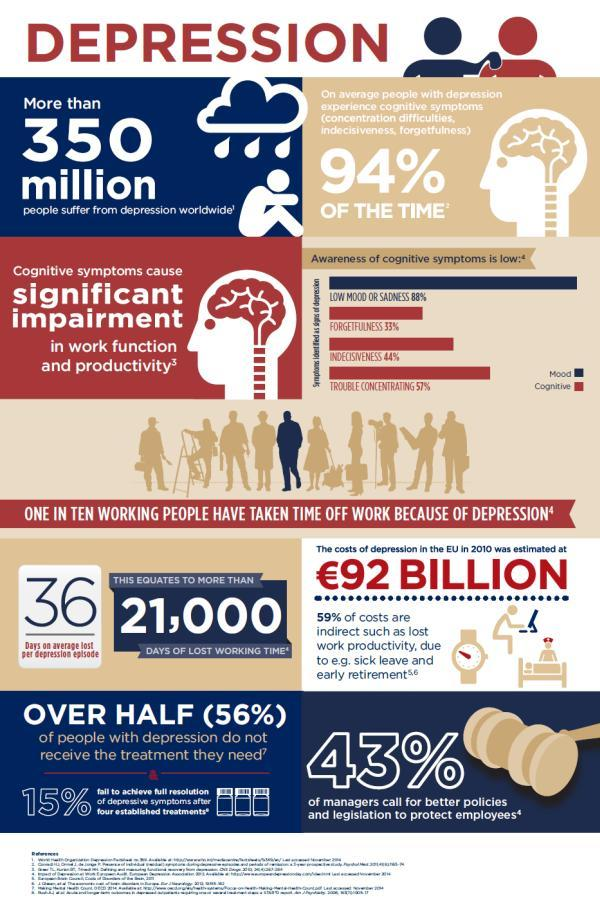What is the percentage of forgetfulness and sadness when taken together?
Answer the question with a short phrase. 121% What percentage of people with depression receive the treatment they need? 44% Which color is used to represent cognitive-white, red, or blue? red 